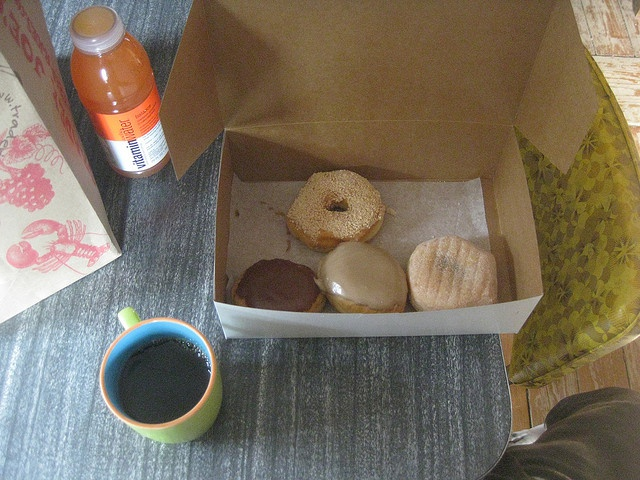Describe the objects in this image and their specific colors. I can see dining table in brown, gray, black, darkgray, and lightblue tones, cup in brown, black, blue, gray, and ivory tones, bottle in brown, salmon, white, and orange tones, donut in brown, gray, maroon, tan, and olive tones, and donut in brown, tan, and gray tones in this image. 